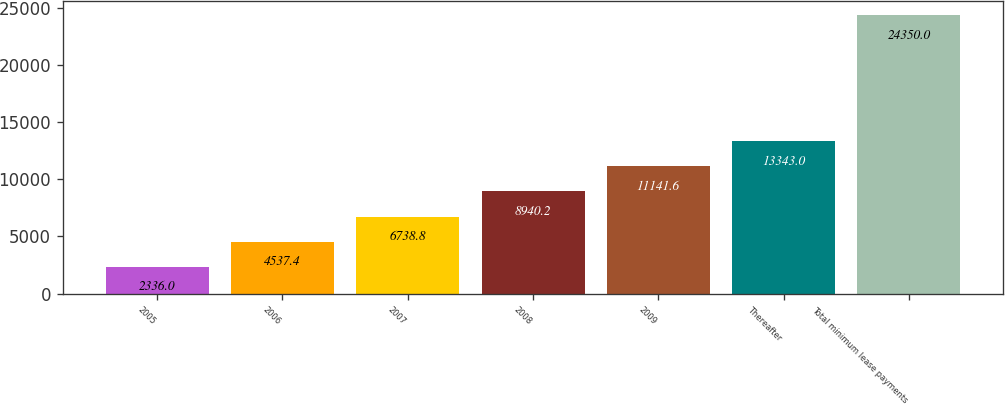Convert chart to OTSL. <chart><loc_0><loc_0><loc_500><loc_500><bar_chart><fcel>2005<fcel>2006<fcel>2007<fcel>2008<fcel>2009<fcel>Thereafter<fcel>Total minimum lease payments<nl><fcel>2336<fcel>4537.4<fcel>6738.8<fcel>8940.2<fcel>11141.6<fcel>13343<fcel>24350<nl></chart> 